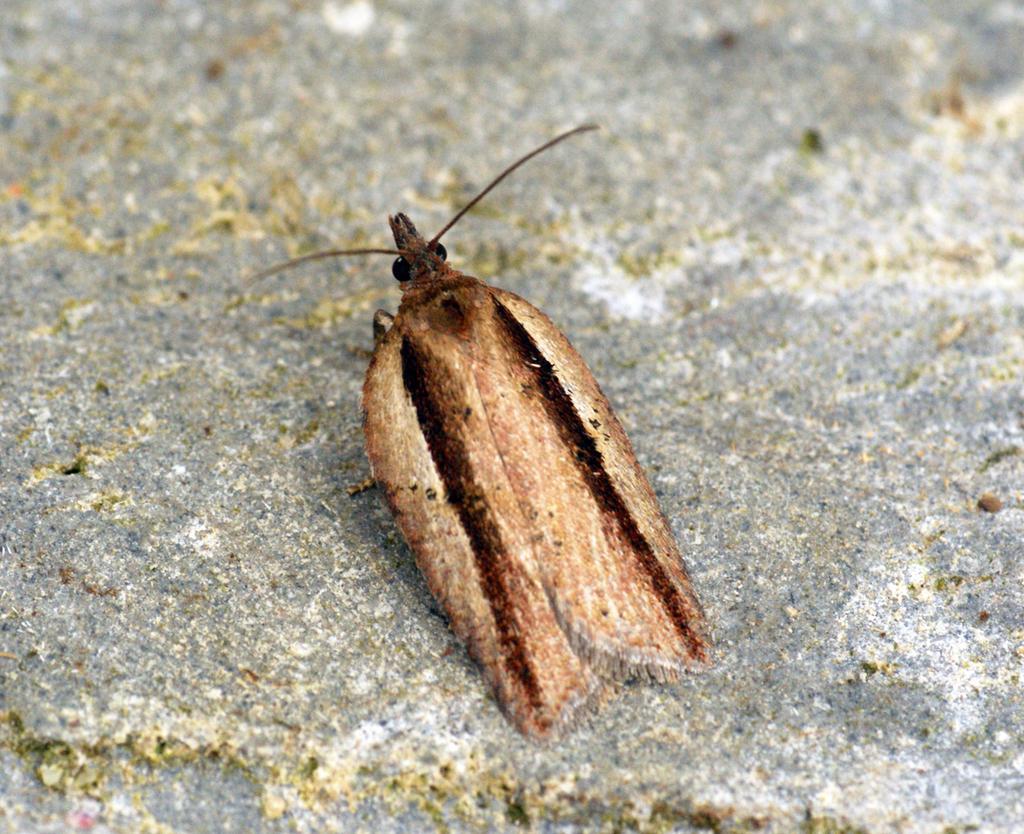Could you give a brief overview of what you see in this image? In this picture there is brown color insect sitting on the concrete ground. 